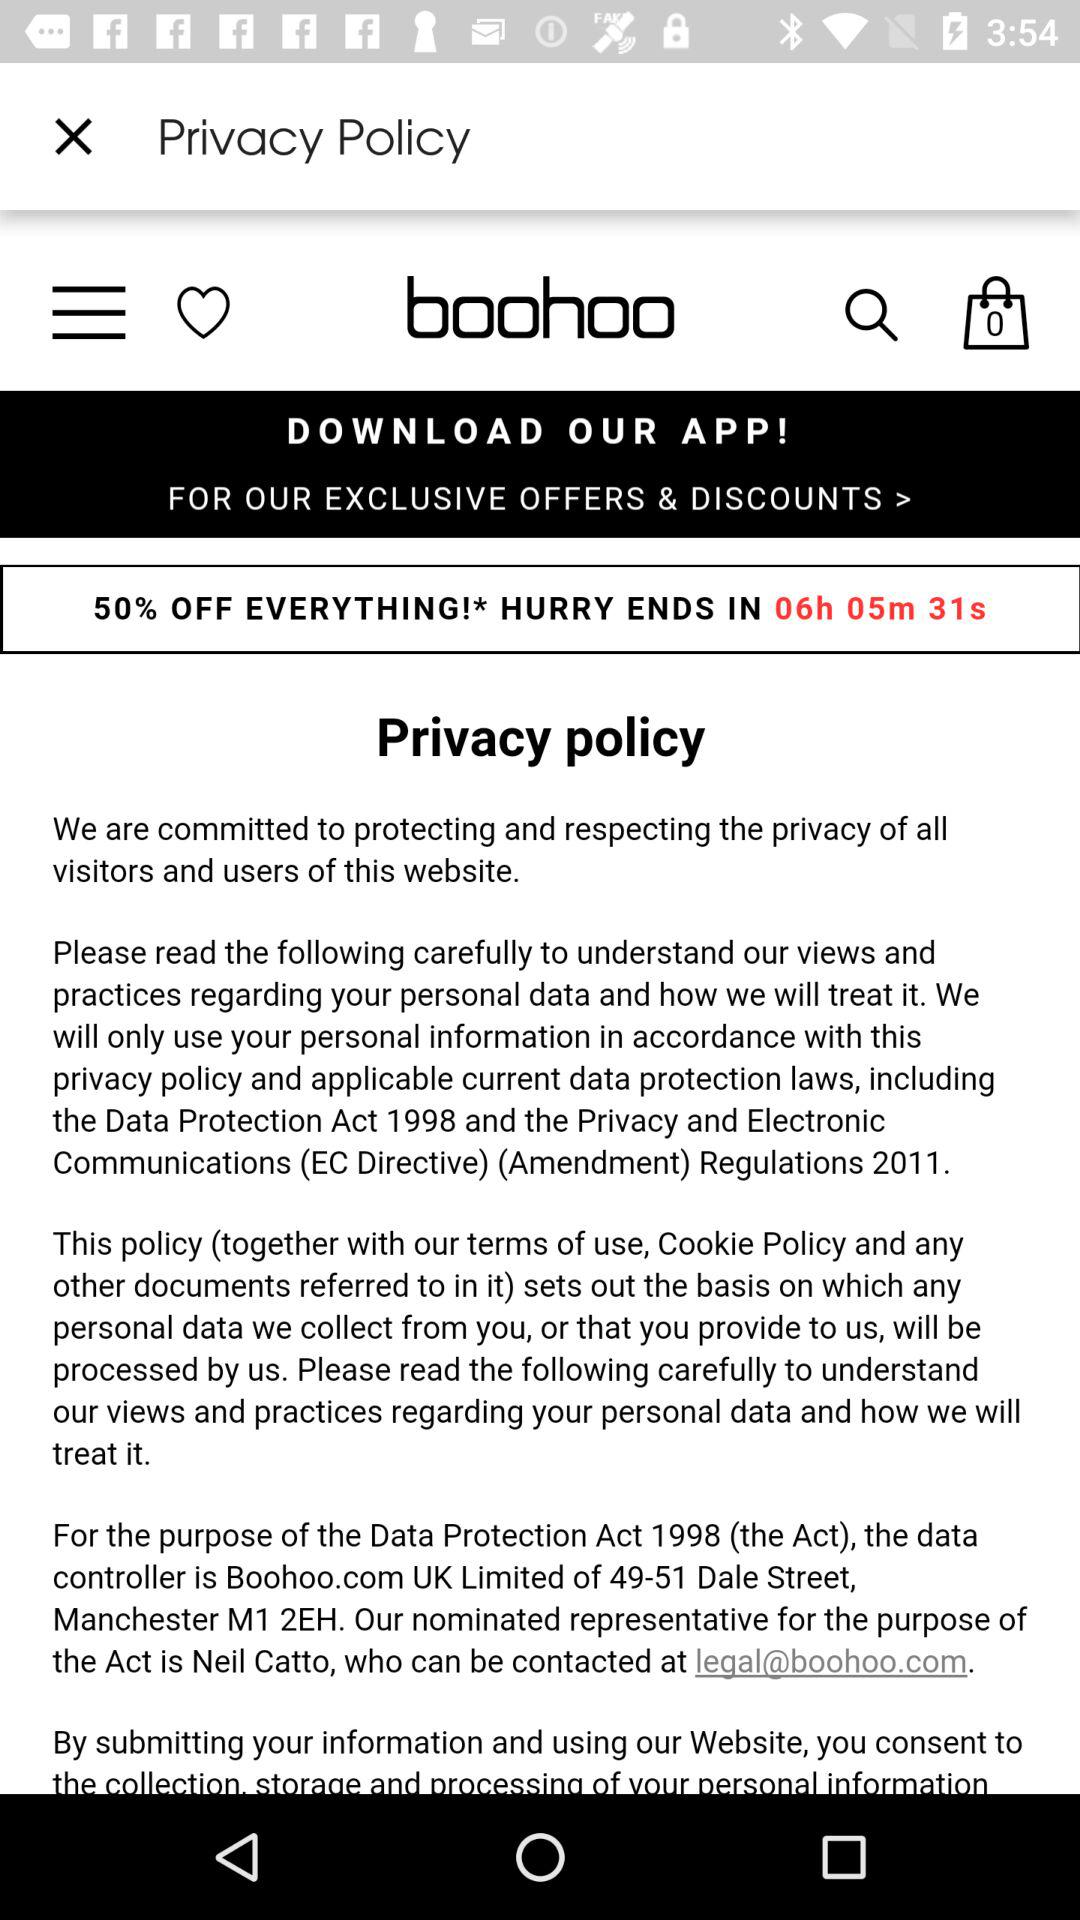What percentage is off on everything? The percentage is 50. 